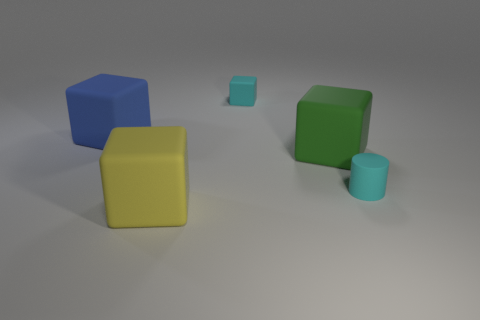Add 1 blue objects. How many objects exist? 6 Subtract all cylinders. How many objects are left? 4 Add 5 green blocks. How many green blocks are left? 6 Add 2 big green matte things. How many big green matte things exist? 3 Subtract 0 brown cylinders. How many objects are left? 5 Subtract all big matte objects. Subtract all small cyan blocks. How many objects are left? 1 